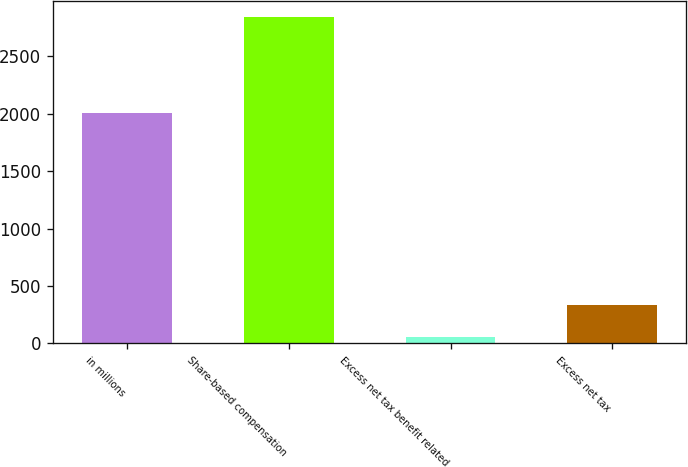<chart> <loc_0><loc_0><loc_500><loc_500><bar_chart><fcel>in millions<fcel>Share-based compensation<fcel>Excess net tax benefit related<fcel>Excess net tax<nl><fcel>2011<fcel>2843<fcel>55<fcel>333.8<nl></chart> 